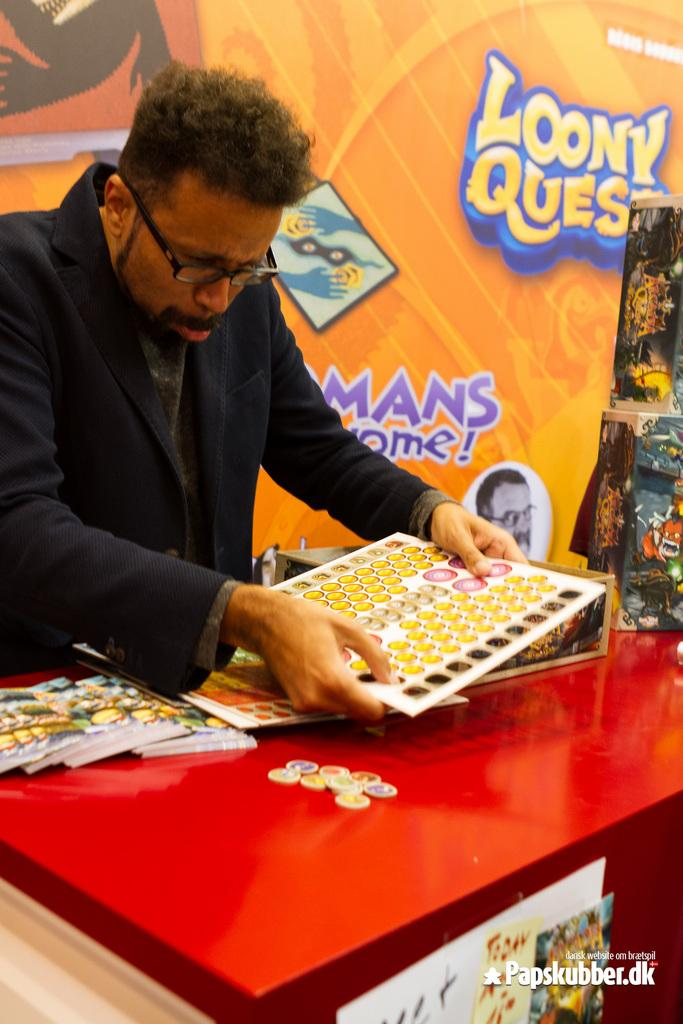What is the main subject of the picture? The main subject of the picture is a man standing. What is the man wearing in the picture? The man is wearing a blazer. What is the man holding in the picture? The man is holding an object. What can be seen in the background of the picture? There is a banner in the background of the picture. How many clocks are visible on the man's wrist in the image? There are no clocks visible on the man's wrist in the image. What type of lock is securing the banner in the background? There is no lock present in the image, as the banner is not secured by any lock. 